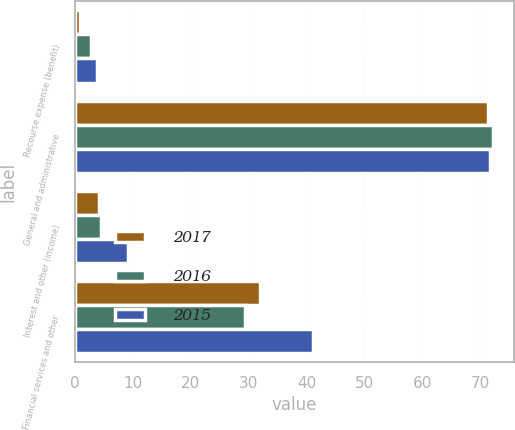<chart> <loc_0><loc_0><loc_500><loc_500><stacked_bar_chart><ecel><fcel>Recourse expense (benefit)<fcel>General and administrative<fcel>Interest and other (income)<fcel>Financial services and other<nl><fcel>2017<fcel>0.8<fcel>71.3<fcel>4.1<fcel>32<nl><fcel>2016<fcel>2.8<fcel>72.3<fcel>4.4<fcel>29.3<nl><fcel>2015<fcel>3.8<fcel>71.7<fcel>9.1<fcel>41.2<nl></chart> 